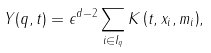Convert formula to latex. <formula><loc_0><loc_0><loc_500><loc_500>Y ( q , t ) = \epsilon ^ { d - 2 } \sum _ { i \in I _ { q } } { K \left ( t , x _ { i } , m _ { i } \right ) } ,</formula> 